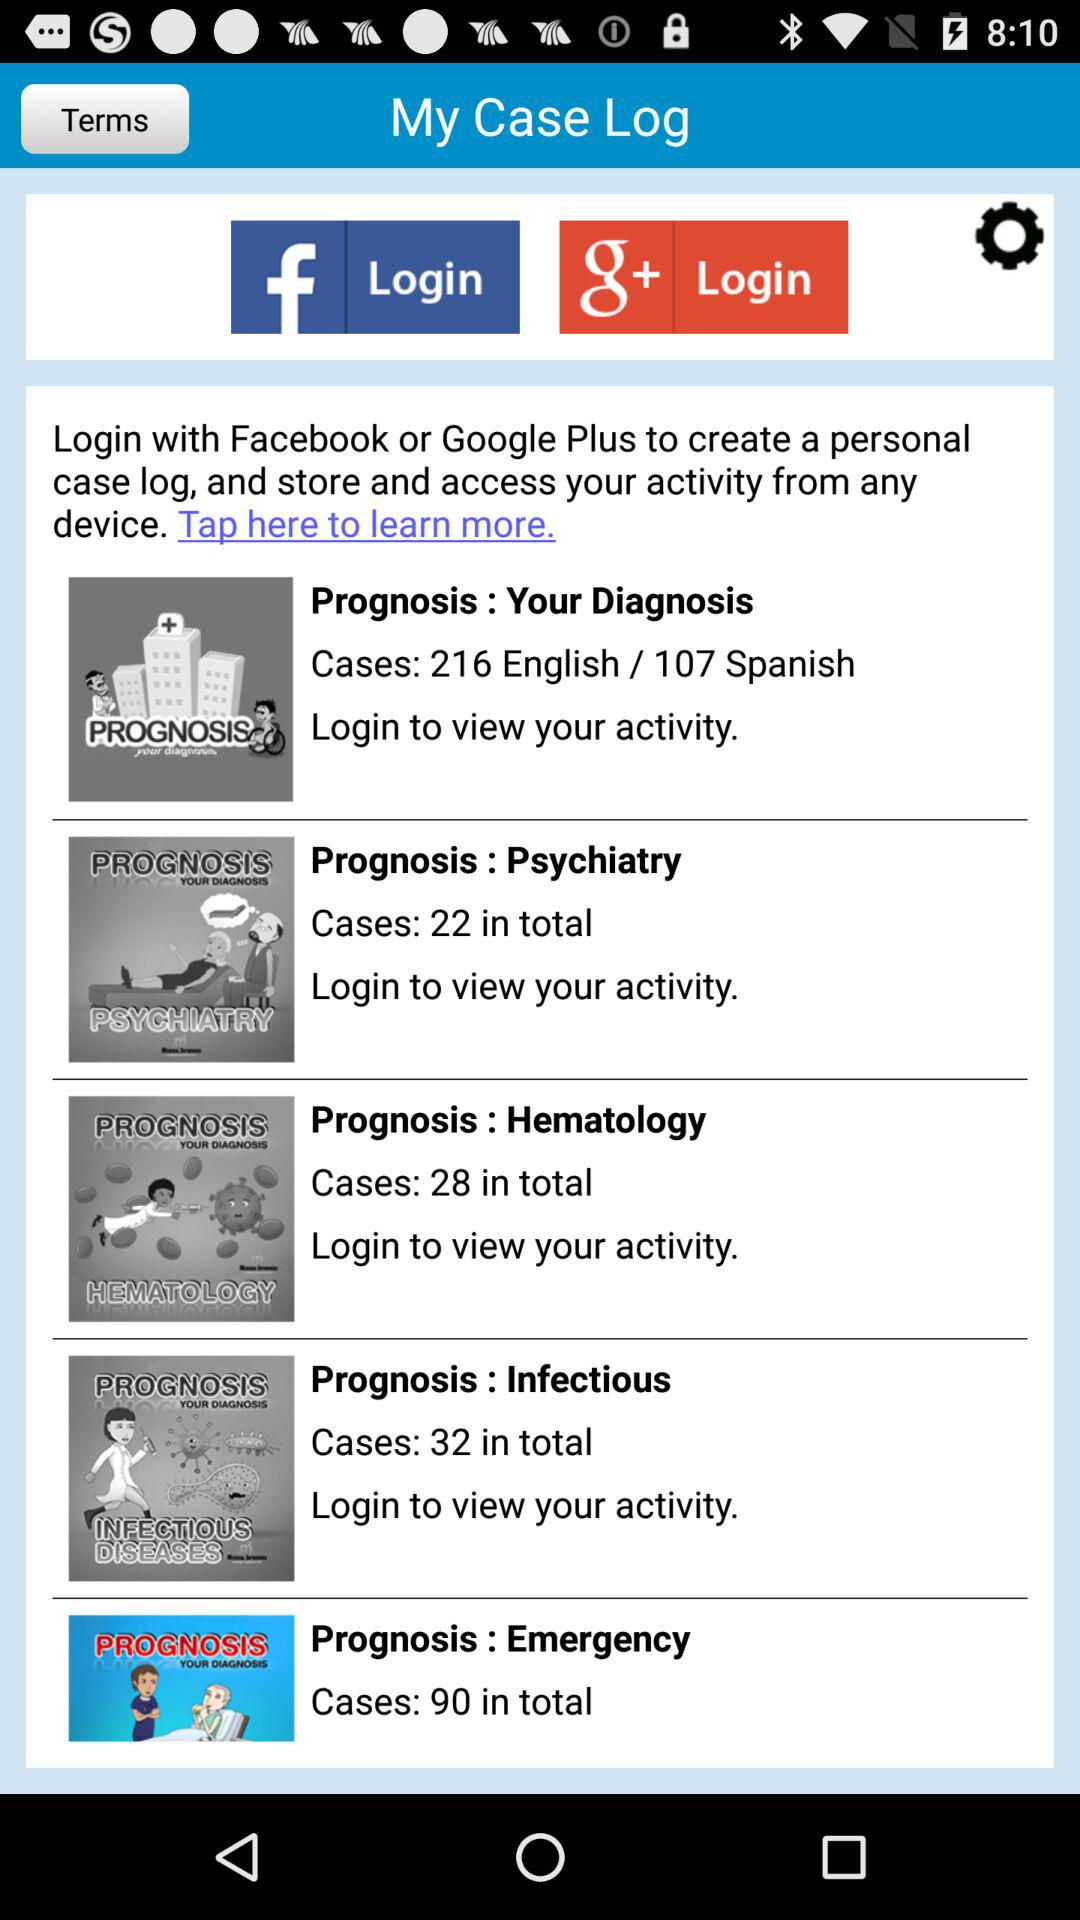What is the total number of psychiatric cases? The total number of psychiatric cases is 22. 